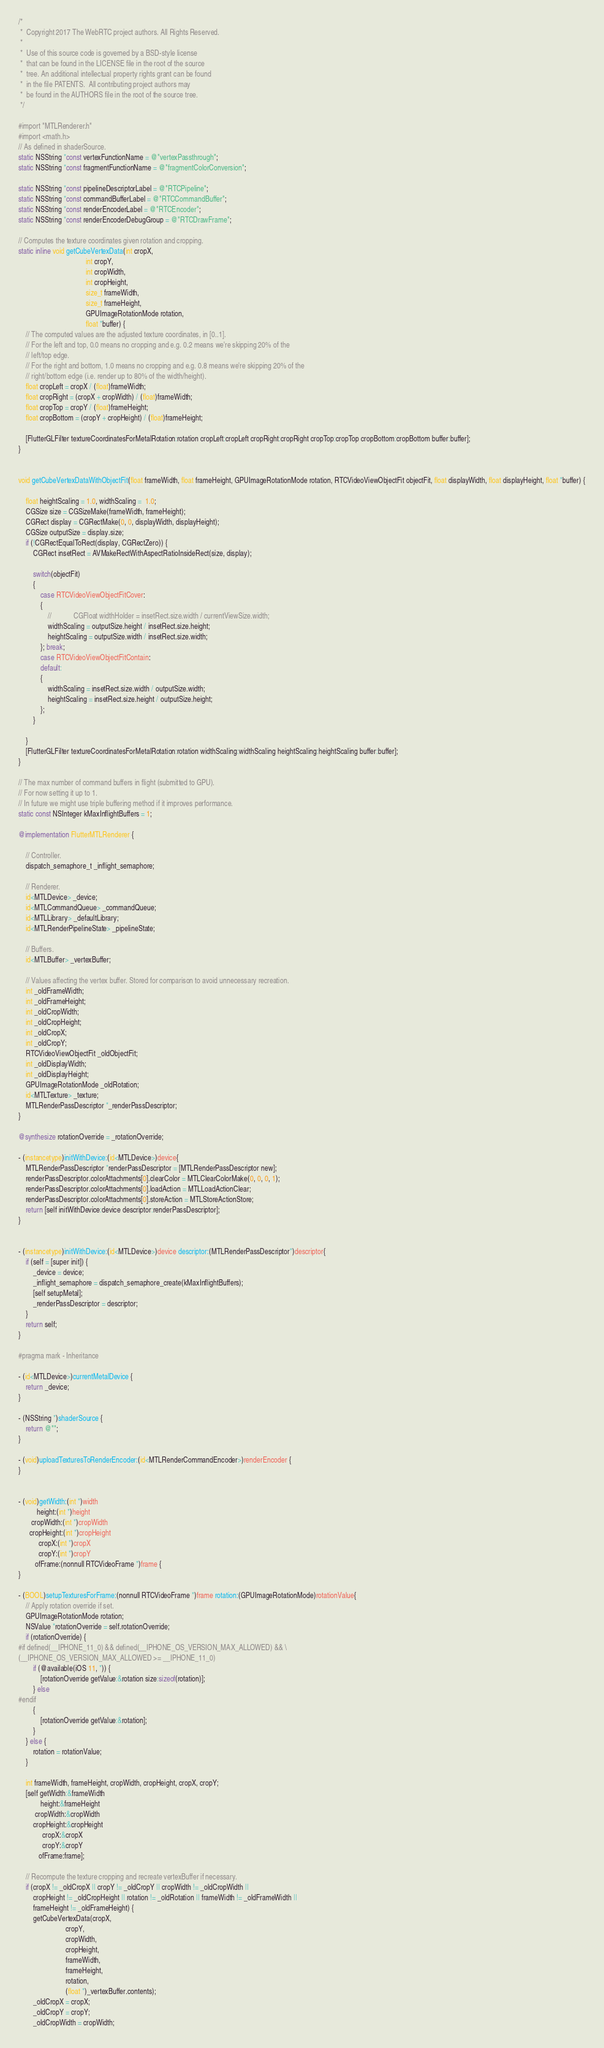<code> <loc_0><loc_0><loc_500><loc_500><_ObjectiveC_>/*
 *  Copyright 2017 The WebRTC project authors. All Rights Reserved.
 *
 *  Use of this source code is governed by a BSD-style license
 *  that can be found in the LICENSE file in the root of the source
 *  tree. An additional intellectual property rights grant can be found
 *  in the file PATENTS.  All contributing project authors may
 *  be found in the AUTHORS file in the root of the source tree.
 */

#import "MTLRenderer.h"
#import <math.h>
// As defined in shaderSource.
static NSString *const vertexFunctionName = @"vertexPassthrough";
static NSString *const fragmentFunctionName = @"fragmentColorConversion";

static NSString *const pipelineDescriptorLabel = @"RTCPipeline";
static NSString *const commandBufferLabel = @"RTCCommandBuffer";
static NSString *const renderEncoderLabel = @"RTCEncoder";
static NSString *const renderEncoderDebugGroup = @"RTCDrawFrame";

// Computes the texture coordinates given rotation and cropping.
static inline void getCubeVertexData(int cropX,
                                     int cropY,
                                     int cropWidth,
                                     int cropHeight,
                                     size_t frameWidth,
                                     size_t frameHeight,
                                     GPUImageRotationMode rotation,
                                     float *buffer) {
    // The computed values are the adjusted texture coordinates, in [0..1].
    // For the left and top, 0.0 means no cropping and e.g. 0.2 means we're skipping 20% of the
    // left/top edge.
    // For the right and bottom, 1.0 means no cropping and e.g. 0.8 means we're skipping 20% of the
    // right/bottom edge (i.e. render up to 80% of the width/height).
    float cropLeft = cropX / (float)frameWidth;
    float cropRight = (cropX + cropWidth) / (float)frameWidth;
    float cropTop = cropY / (float)frameHeight;
    float cropBottom = (cropY + cropHeight) / (float)frameHeight;
    
    [FlutterGLFilter textureCoordinatesForMetalRotation:rotation cropLeft:cropLeft cropRight:cropRight cropTop:cropTop cropBottom:cropBottom buffer:buffer];
}


void getCubeVertexDataWithObjectFit(float frameWidth, float frameHeight, GPUImageRotationMode rotation, RTCVideoViewObjectFit objectFit, float displayWidth, float displayHeight, float *buffer) {
    
    float heightScaling = 1.0, widthScaling =  1.0;
    CGSize size = CGSizeMake(frameWidth, frameHeight);
    CGRect display = CGRectMake(0, 0, displayWidth, displayHeight);
    CGSize outputSize = display.size;
    if (!CGRectEqualToRect(display, CGRectZero)) {
        CGRect insetRect = AVMakeRectWithAspectRatioInsideRect(size, display);

        switch(objectFit)
        {
            case RTCVideoViewObjectFitCover:
            {
                //            CGFloat widthHolder = insetRect.size.width / currentViewSize.width;
                widthScaling = outputSize.height / insetRect.size.height;
                heightScaling = outputSize.width / insetRect.size.width;
            }; break;
            case RTCVideoViewObjectFitContain:
            default:
            {
                widthScaling = insetRect.size.width / outputSize.width;
                heightScaling = insetRect.size.height / outputSize.height;
            };
        }

    }
    [FlutterGLFilter textureCoordinatesForMetalRotation:rotation widthScaling:widthScaling heightScaling:heightScaling buffer:buffer];
}

// The max number of command buffers in flight (submitted to GPU).
// For now setting it up to 1.
// In future we might use triple buffering method if it improves performance.
static const NSInteger kMaxInflightBuffers = 1;

@implementation FlutterMTLRenderer {
    
    // Controller.
    dispatch_semaphore_t _inflight_semaphore;
    
    // Renderer.
    id<MTLDevice> _device;
    id<MTLCommandQueue> _commandQueue;
    id<MTLLibrary> _defaultLibrary;
    id<MTLRenderPipelineState> _pipelineState;
    
    // Buffers.
    id<MTLBuffer> _vertexBuffer;
    
    // Values affecting the vertex buffer. Stored for comparison to avoid unnecessary recreation.
    int _oldFrameWidth;
    int _oldFrameHeight;
    int _oldCropWidth;
    int _oldCropHeight;
    int _oldCropX;
    int _oldCropY;
    RTCVideoViewObjectFit _oldObjectFit;
    int _oldDisplayWidth;
    int _oldDisplayHeight;
    GPUImageRotationMode _oldRotation;
    id<MTLTexture> _texture;
    MTLRenderPassDescriptor *_renderPassDescriptor;
}

@synthesize rotationOverride = _rotationOverride;

- (instancetype)initWithDevice:(id<MTLDevice>)device{
    MTLRenderPassDescriptor *renderPassDescriptor = [MTLRenderPassDescriptor new];
    renderPassDescriptor.colorAttachments[0].clearColor = MTLClearColorMake(0, 0, 0, 1);
    renderPassDescriptor.colorAttachments[0].loadAction = MTLLoadActionClear;
    renderPassDescriptor.colorAttachments[0].storeAction = MTLStoreActionStore;
    return [self initWithDevice:device descriptor:renderPassDescriptor];
}


- (instancetype)initWithDevice:(id<MTLDevice>)device descriptor:(MTLRenderPassDescriptor*)descriptor{
    if (self = [super init]) {
        _device = device;
        _inflight_semaphore = dispatch_semaphore_create(kMaxInflightBuffers);
        [self setupMetal];
        _renderPassDescriptor = descriptor;
    }
    return self;
}

#pragma mark - Inheritance

- (id<MTLDevice>)currentMetalDevice {
    return _device;
}

- (NSString *)shaderSource {
    return @"";
}

- (void)uploadTexturesToRenderEncoder:(id<MTLRenderCommandEncoder>)renderEncoder {
}


- (void)getWidth:(int *)width
          height:(int *)height
       cropWidth:(int *)cropWidth
      cropHeight:(int *)cropHeight
           cropX:(int *)cropX
           cropY:(int *)cropY
         ofFrame:(nonnull RTCVideoFrame *)frame {
}

- (BOOL)setupTexturesForFrame:(nonnull RTCVideoFrame *)frame rotation:(GPUImageRotationMode)rotationValue{
    // Apply rotation override if set.
    GPUImageRotationMode rotation;
    NSValue *rotationOverride = self.rotationOverride;
    if (rotationOverride) {
#if defined(__IPHONE_11_0) && defined(__IPHONE_OS_VERSION_MAX_ALLOWED) && \
(__IPHONE_OS_VERSION_MAX_ALLOWED >= __IPHONE_11_0)
        if (@available(iOS 11, *)) {
            [rotationOverride getValue:&rotation size:sizeof(rotation)];
        } else
#endif
        {
            [rotationOverride getValue:&rotation];
        }
    } else {
        rotation = rotationValue;
    }
    
    int frameWidth, frameHeight, cropWidth, cropHeight, cropX, cropY;
    [self getWidth:&frameWidth
            height:&frameHeight
         cropWidth:&cropWidth
        cropHeight:&cropHeight
             cropX:&cropX
             cropY:&cropY
           ofFrame:frame];
    
    // Recompute the texture cropping and recreate vertexBuffer if necessary.
    if (cropX != _oldCropX || cropY != _oldCropY || cropWidth != _oldCropWidth ||
        cropHeight != _oldCropHeight || rotation != _oldRotation || frameWidth != _oldFrameWidth ||
        frameHeight != _oldFrameHeight) {
        getCubeVertexData(cropX,
                          cropY,
                          cropWidth,
                          cropHeight,
                          frameWidth,
                          frameHeight,
                          rotation,
                          (float *)_vertexBuffer.contents);
        _oldCropX = cropX;
        _oldCropY = cropY;
        _oldCropWidth = cropWidth;</code> 